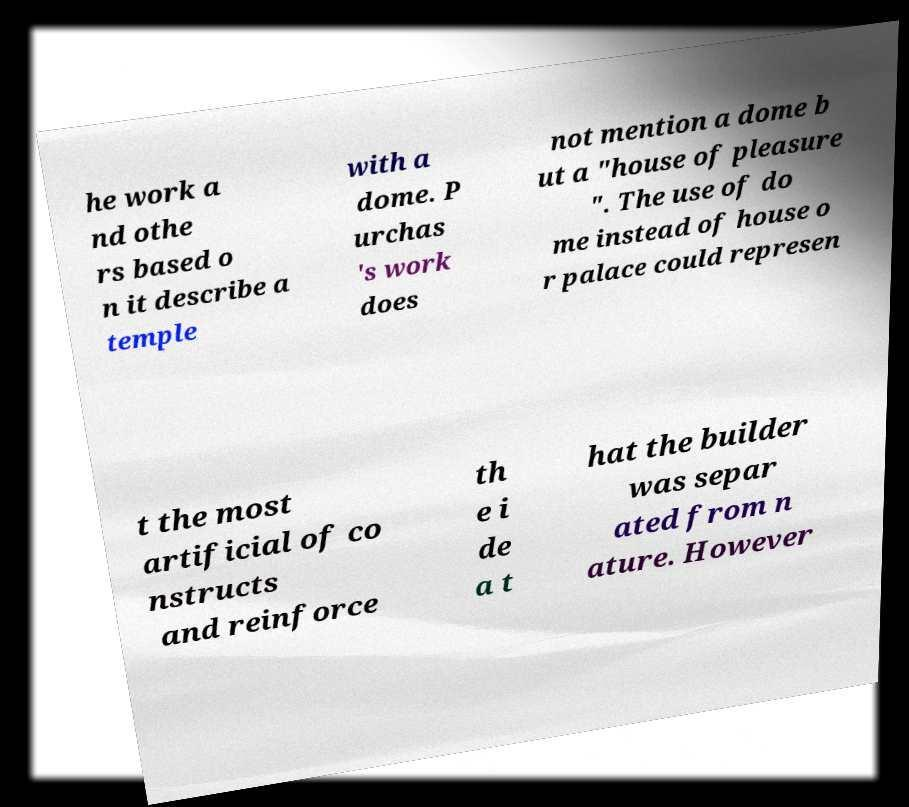There's text embedded in this image that I need extracted. Can you transcribe it verbatim? he work a nd othe rs based o n it describe a temple with a dome. P urchas 's work does not mention a dome b ut a "house of pleasure ". The use of do me instead of house o r palace could represen t the most artificial of co nstructs and reinforce th e i de a t hat the builder was separ ated from n ature. However 